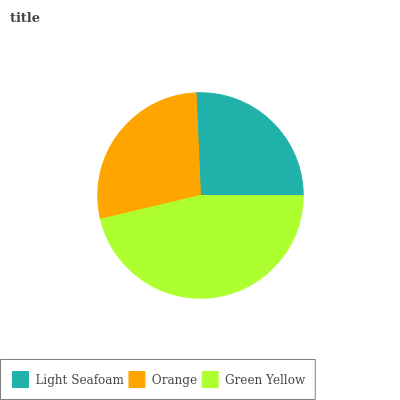Is Light Seafoam the minimum?
Answer yes or no. Yes. Is Green Yellow the maximum?
Answer yes or no. Yes. Is Orange the minimum?
Answer yes or no. No. Is Orange the maximum?
Answer yes or no. No. Is Orange greater than Light Seafoam?
Answer yes or no. Yes. Is Light Seafoam less than Orange?
Answer yes or no. Yes. Is Light Seafoam greater than Orange?
Answer yes or no. No. Is Orange less than Light Seafoam?
Answer yes or no. No. Is Orange the high median?
Answer yes or no. Yes. Is Orange the low median?
Answer yes or no. Yes. Is Light Seafoam the high median?
Answer yes or no. No. Is Light Seafoam the low median?
Answer yes or no. No. 